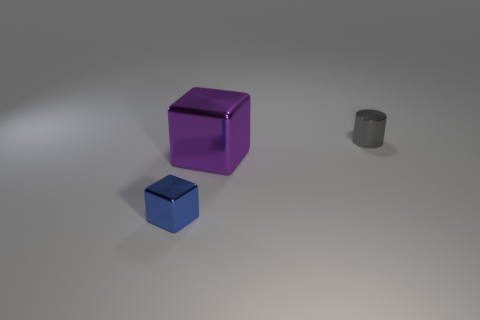Is the number of small blue metallic blocks greater than the number of large red metal cylinders?
Give a very brief answer. Yes. The big metallic block has what color?
Your answer should be compact. Purple. Does the tiny metal thing in front of the small shiny cylinder have the same shape as the large purple metal object?
Provide a succinct answer. Yes. Is the number of small gray metal objects that are left of the large metal block less than the number of shiny things in front of the gray metallic thing?
Offer a terse response. Yes. There is a block behind the blue cube; what material is it?
Your answer should be very brief. Metal. Are there any other objects of the same size as the gray shiny thing?
Offer a very short reply. Yes. Does the large purple metallic thing have the same shape as the thing that is on the left side of the purple cube?
Give a very brief answer. Yes. There is a metallic block that is to the right of the blue shiny cube; is its size the same as the shiny object that is right of the purple shiny block?
Provide a succinct answer. No. What number of other things are the same shape as the purple object?
Offer a very short reply. 1. There is a block right of the tiny shiny thing that is on the left side of the tiny cylinder; what is it made of?
Offer a terse response. Metal. 